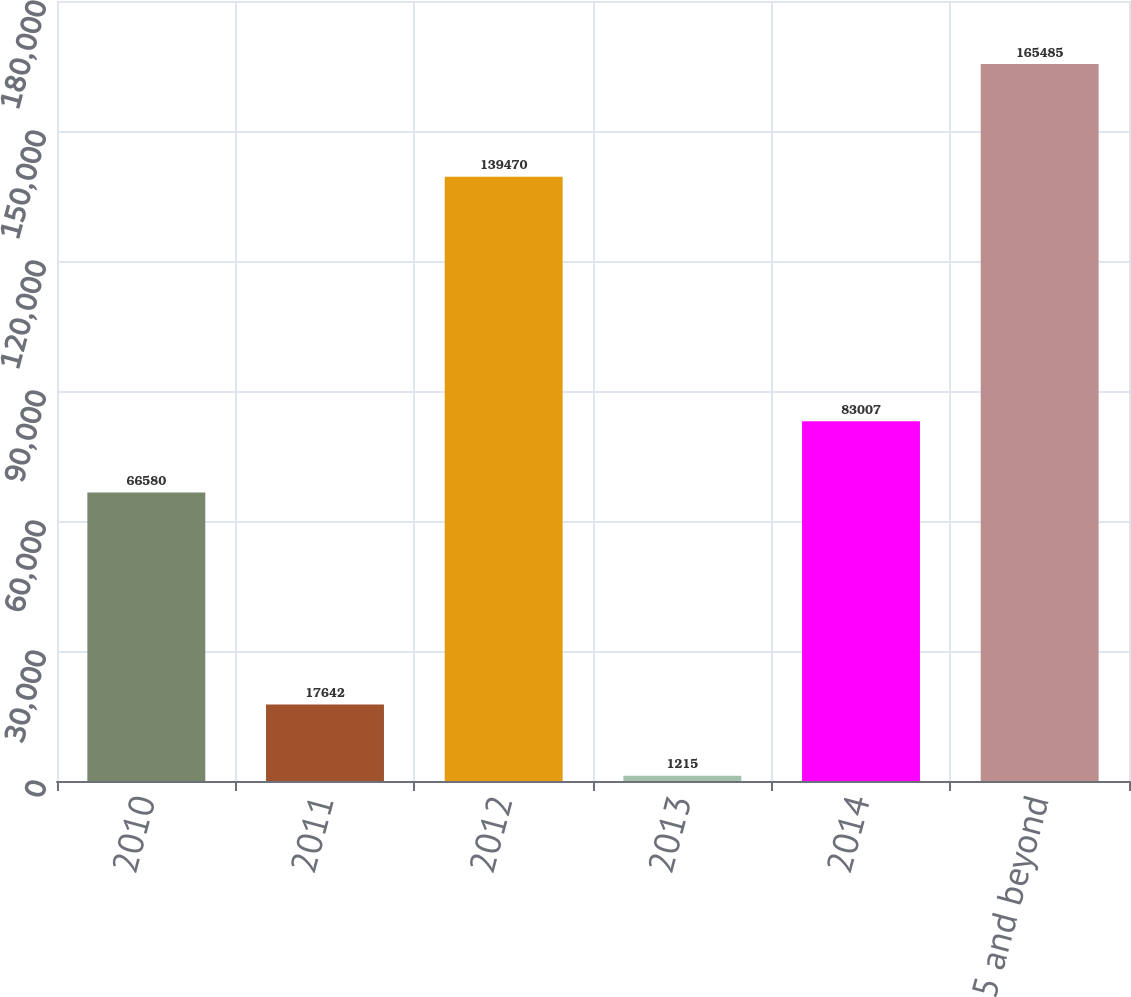Convert chart to OTSL. <chart><loc_0><loc_0><loc_500><loc_500><bar_chart><fcel>2010<fcel>2011<fcel>2012<fcel>2013<fcel>2014<fcel>2015 and beyond<nl><fcel>66580<fcel>17642<fcel>139470<fcel>1215<fcel>83007<fcel>165485<nl></chart> 